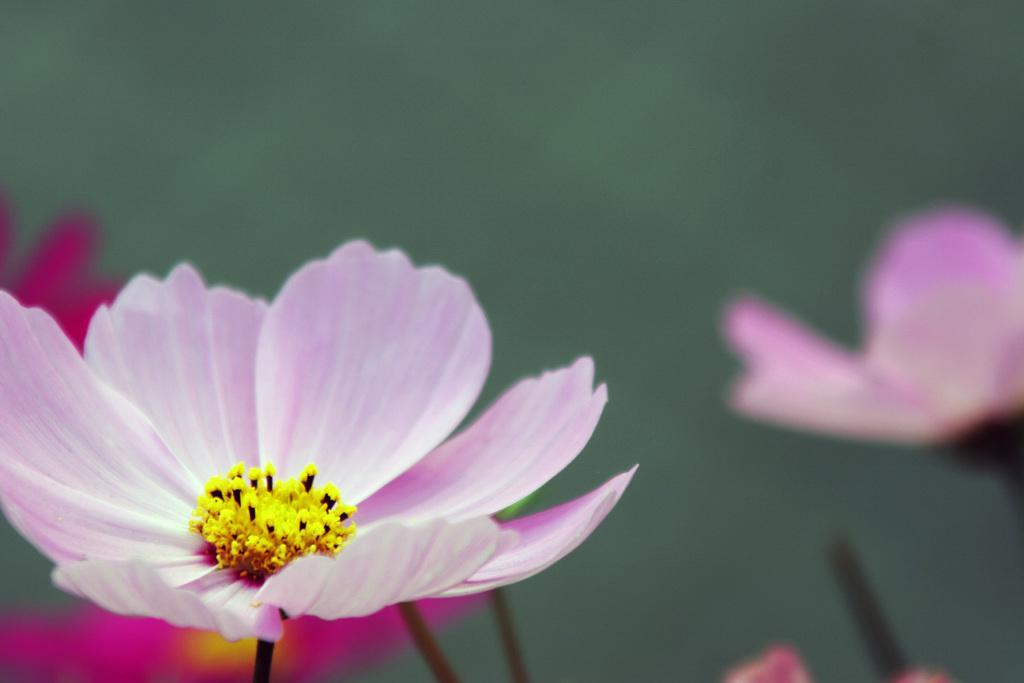What type of plants can be seen in the image? There are flowers in the image. Can you describe the structure of the flowers? The flowers have stems. What type of faucet is visible in the image? There is no faucet present in the image; it only features flowers with stems. 